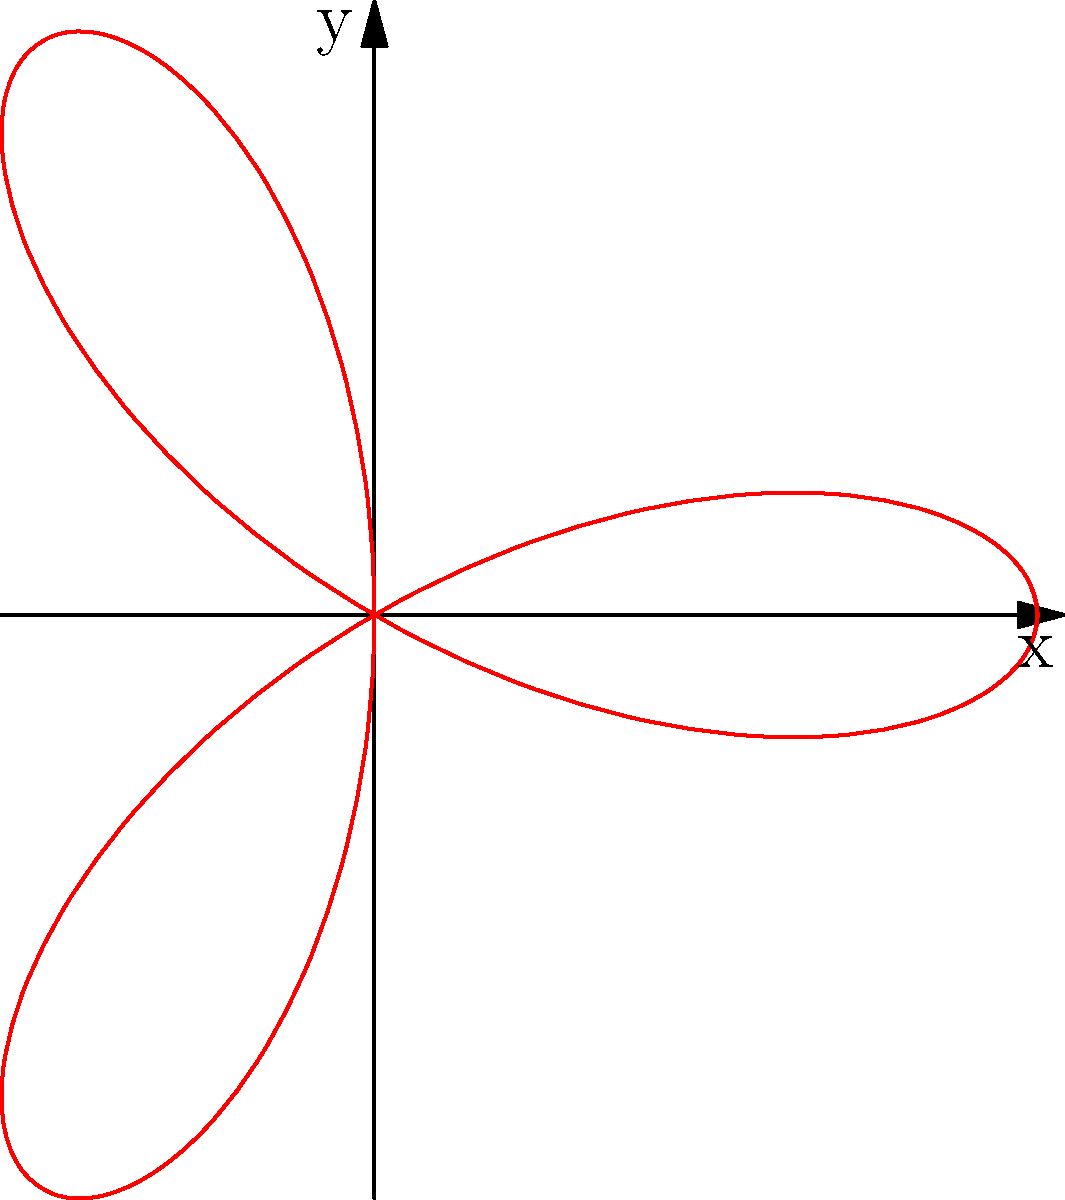In the context of rhythm patterns, how might the number of petals in this rose curve ($$r = \cos(3\theta)$$) relate to the time signature in a Big Pun-inspired verse? 1. The rose curve equation is given by $$r = \cos(3\theta)$$.

2. The number of petals in a rose curve is determined by the coefficient of θ in the cosine function. In this case, it's 3.

3. When the coefficient is odd (like 3), the number of petals equals the coefficient. So this curve has 3 petals.

4. In music theory, the number 3 often relates to triple meter time signatures, such as 3/4 or 6/8.

5. Big Pun often used complex rhythms and wordplay. A 3/4 time signature could create an interesting, waltz-like flow that challenges the typical 4/4 structure of hip-hop.

6. This triplet feel could be used to create a unique rhythm pattern in a verse, with each petal representing a measure or a major beat in the flow.
Answer: 3/4 time signature 